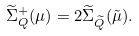<formula> <loc_0><loc_0><loc_500><loc_500>\widetilde { \Sigma } _ { Q } ^ { + } ( \mu ) = 2 \widetilde { \Sigma } _ { \widetilde { Q } } ( \tilde { \mu } ) .</formula> 